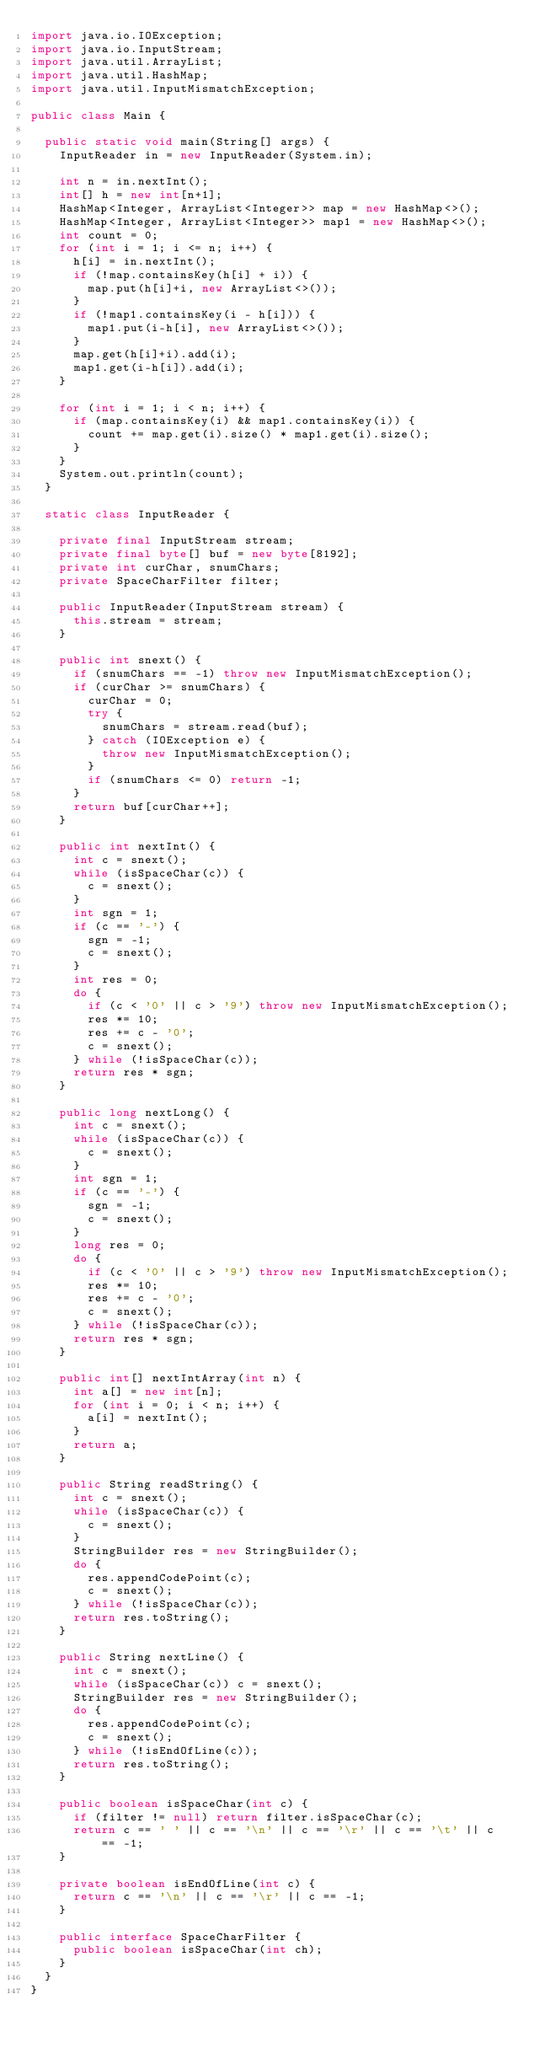<code> <loc_0><loc_0><loc_500><loc_500><_Java_>import java.io.IOException;
import java.io.InputStream;
import java.util.ArrayList;
import java.util.HashMap;
import java.util.InputMismatchException;

public class Main {

  public static void main(String[] args) {
    InputReader in = new InputReader(System.in);

    int n = in.nextInt();
    int[] h = new int[n+1];
    HashMap<Integer, ArrayList<Integer>> map = new HashMap<>();
    HashMap<Integer, ArrayList<Integer>> map1 = new HashMap<>();
    int count = 0;
    for (int i = 1; i <= n; i++) {
      h[i] = in.nextInt();
      if (!map.containsKey(h[i] + i)) {
        map.put(h[i]+i, new ArrayList<>());
      }
      if (!map1.containsKey(i - h[i])) {
        map1.put(i-h[i], new ArrayList<>());
      }
      map.get(h[i]+i).add(i);
      map1.get(i-h[i]).add(i);
    }

    for (int i = 1; i < n; i++) {
      if (map.containsKey(i) && map1.containsKey(i)) {
        count += map.get(i).size() * map1.get(i).size();
      }
    }
    System.out.println(count);
  }

  static class InputReader {

    private final InputStream stream;
    private final byte[] buf = new byte[8192];
    private int curChar, snumChars;
    private SpaceCharFilter filter;

    public InputReader(InputStream stream) {
      this.stream = stream;
    }

    public int snext() {
      if (snumChars == -1) throw new InputMismatchException();
      if (curChar >= snumChars) {
        curChar = 0;
        try {
          snumChars = stream.read(buf);
        } catch (IOException e) {
          throw new InputMismatchException();
        }
        if (snumChars <= 0) return -1;
      }
      return buf[curChar++];
    }

    public int nextInt() {
      int c = snext();
      while (isSpaceChar(c)) {
        c = snext();
      }
      int sgn = 1;
      if (c == '-') {
        sgn = -1;
        c = snext();
      }
      int res = 0;
      do {
        if (c < '0' || c > '9') throw new InputMismatchException();
        res *= 10;
        res += c - '0';
        c = snext();
      } while (!isSpaceChar(c));
      return res * sgn;
    }

    public long nextLong() {
      int c = snext();
      while (isSpaceChar(c)) {
        c = snext();
      }
      int sgn = 1;
      if (c == '-') {
        sgn = -1;
        c = snext();
      }
      long res = 0;
      do {
        if (c < '0' || c > '9') throw new InputMismatchException();
        res *= 10;
        res += c - '0';
        c = snext();
      } while (!isSpaceChar(c));
      return res * sgn;
    }

    public int[] nextIntArray(int n) {
      int a[] = new int[n];
      for (int i = 0; i < n; i++) {
        a[i] = nextInt();
      }
      return a;
    }

    public String readString() {
      int c = snext();
      while (isSpaceChar(c)) {
        c = snext();
      }
      StringBuilder res = new StringBuilder();
      do {
        res.appendCodePoint(c);
        c = snext();
      } while (!isSpaceChar(c));
      return res.toString();
    }

    public String nextLine() {
      int c = snext();
      while (isSpaceChar(c)) c = snext();
      StringBuilder res = new StringBuilder();
      do {
        res.appendCodePoint(c);
        c = snext();
      } while (!isEndOfLine(c));
      return res.toString();
    }

    public boolean isSpaceChar(int c) {
      if (filter != null) return filter.isSpaceChar(c);
      return c == ' ' || c == '\n' || c == '\r' || c == '\t' || c == -1;
    }

    private boolean isEndOfLine(int c) {
      return c == '\n' || c == '\r' || c == -1;
    }

    public interface SpaceCharFilter {
      public boolean isSpaceChar(int ch);
    }
  }
}
</code> 